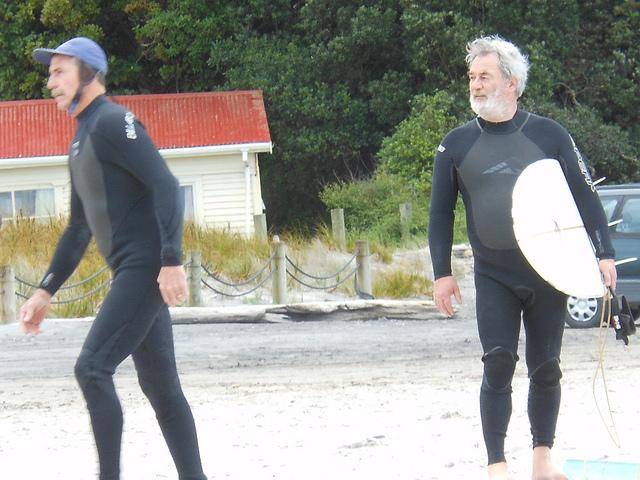Why are there two oval patterns on the right man's pants? Please explain your reasoning. knee protection. The pads are placed over both of his kneecaps. 